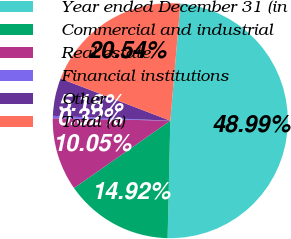<chart> <loc_0><loc_0><loc_500><loc_500><pie_chart><fcel>Year ended December 31 (in<fcel>Commercial and industrial<fcel>Real estate<fcel>Financial institutions<fcel>Other<fcel>Total (a)<nl><fcel>48.99%<fcel>14.92%<fcel>10.05%<fcel>0.32%<fcel>5.18%<fcel>20.54%<nl></chart> 